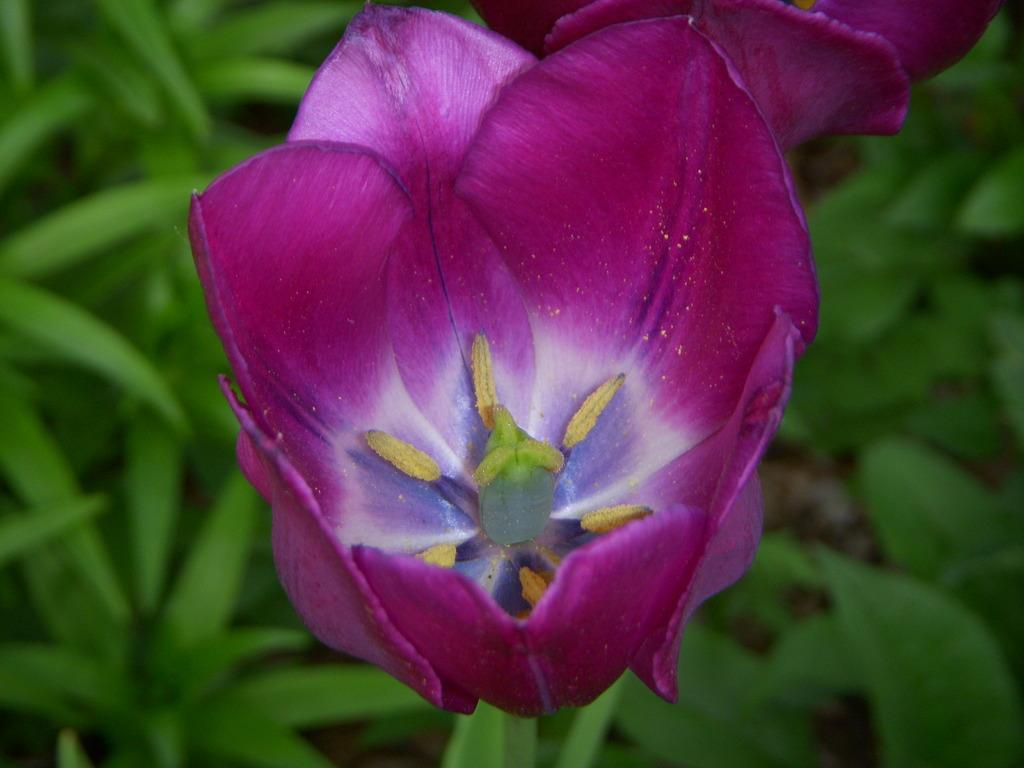What type of plant is featured in the image? There is a flower on a plant in the image. What other parts of the plant can be seen in the image? There are many leaves visible in the image. What actor is performing in the image? There is no actor present in the image; it features a flower on a plant and leaves. What role does the mother play in the image? There is no mother present in the image; it features a flower on a plant and leaves. 